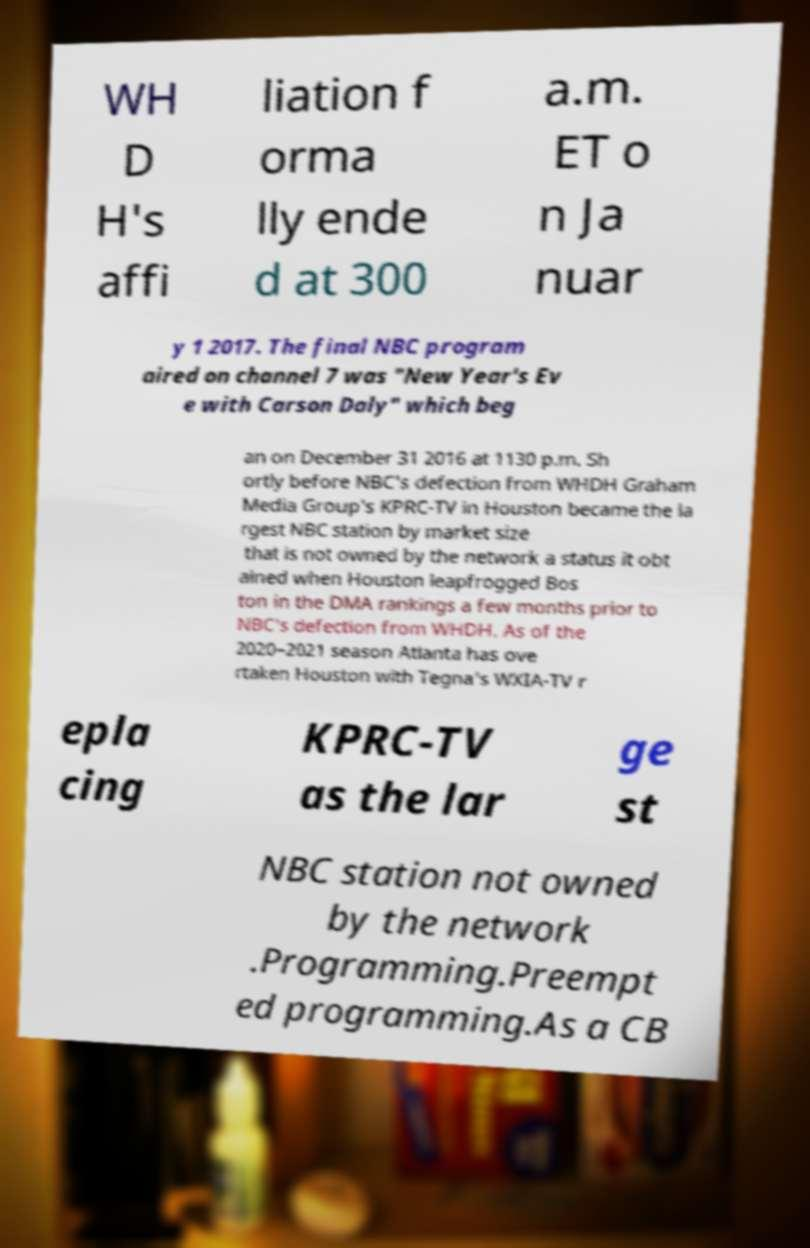Please read and relay the text visible in this image. What does it say? WH D H's affi liation f orma lly ende d at 300 a.m. ET o n Ja nuar y 1 2017. The final NBC program aired on channel 7 was "New Year's Ev e with Carson Daly" which beg an on December 31 2016 at 1130 p.m. Sh ortly before NBC's defection from WHDH Graham Media Group's KPRC-TV in Houston became the la rgest NBC station by market size that is not owned by the network a status it obt ained when Houston leapfrogged Bos ton in the DMA rankings a few months prior to NBC's defection from WHDH. As of the 2020–2021 season Atlanta has ove rtaken Houston with Tegna's WXIA-TV r epla cing KPRC-TV as the lar ge st NBC station not owned by the network .Programming.Preempt ed programming.As a CB 